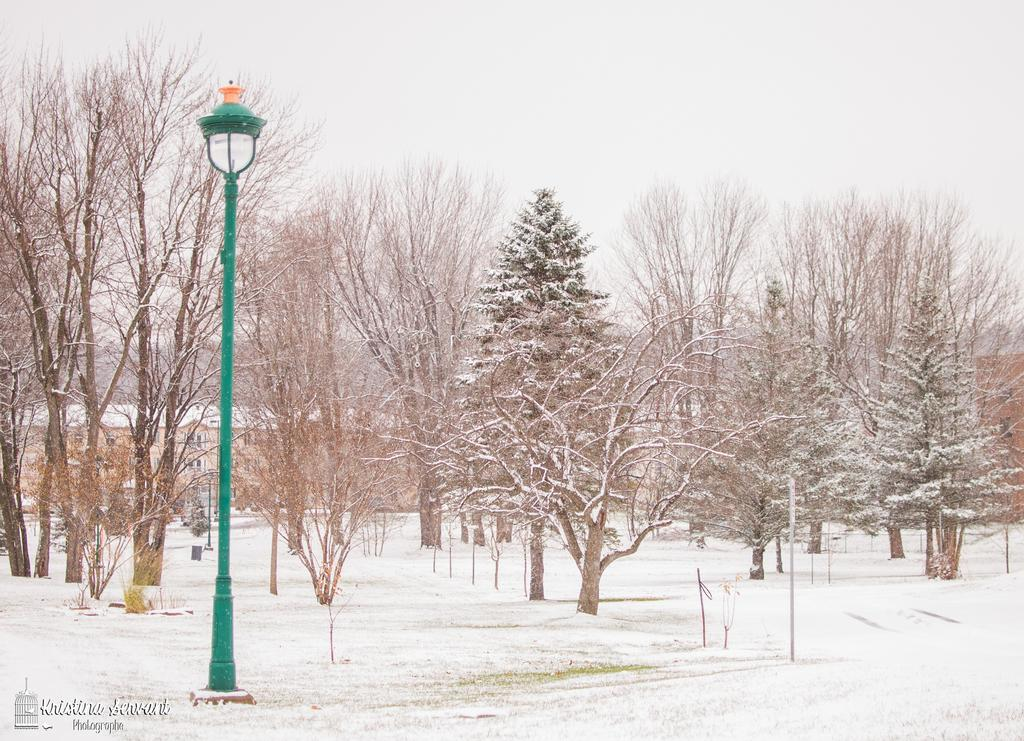What type of surface is shown in the image? The image shows a snow surface. What is placed on the snow surface? There is a pole with a lamp on the snow surface. What can be seen near the pole? Trees are visible near the pole. How is the snow affecting the trees in the image? Snow is present on the trees. What type of stamp can be seen on the pole in the image? There is no stamp present on the pole in the image. What type of cloth is used to cover the lamp in the image? The lamp in the image does not have any cloth covering it. 